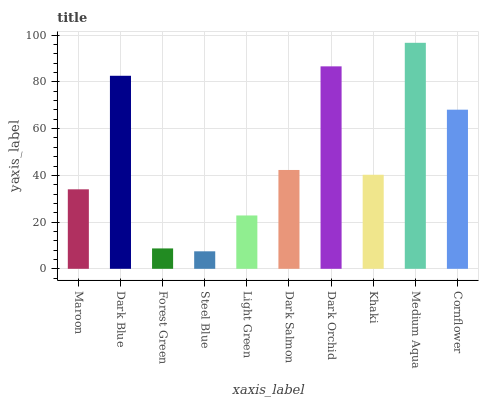Is Steel Blue the minimum?
Answer yes or no. Yes. Is Medium Aqua the maximum?
Answer yes or no. Yes. Is Dark Blue the minimum?
Answer yes or no. No. Is Dark Blue the maximum?
Answer yes or no. No. Is Dark Blue greater than Maroon?
Answer yes or no. Yes. Is Maroon less than Dark Blue?
Answer yes or no. Yes. Is Maroon greater than Dark Blue?
Answer yes or no. No. Is Dark Blue less than Maroon?
Answer yes or no. No. Is Dark Salmon the high median?
Answer yes or no. Yes. Is Khaki the low median?
Answer yes or no. Yes. Is Steel Blue the high median?
Answer yes or no. No. Is Steel Blue the low median?
Answer yes or no. No. 